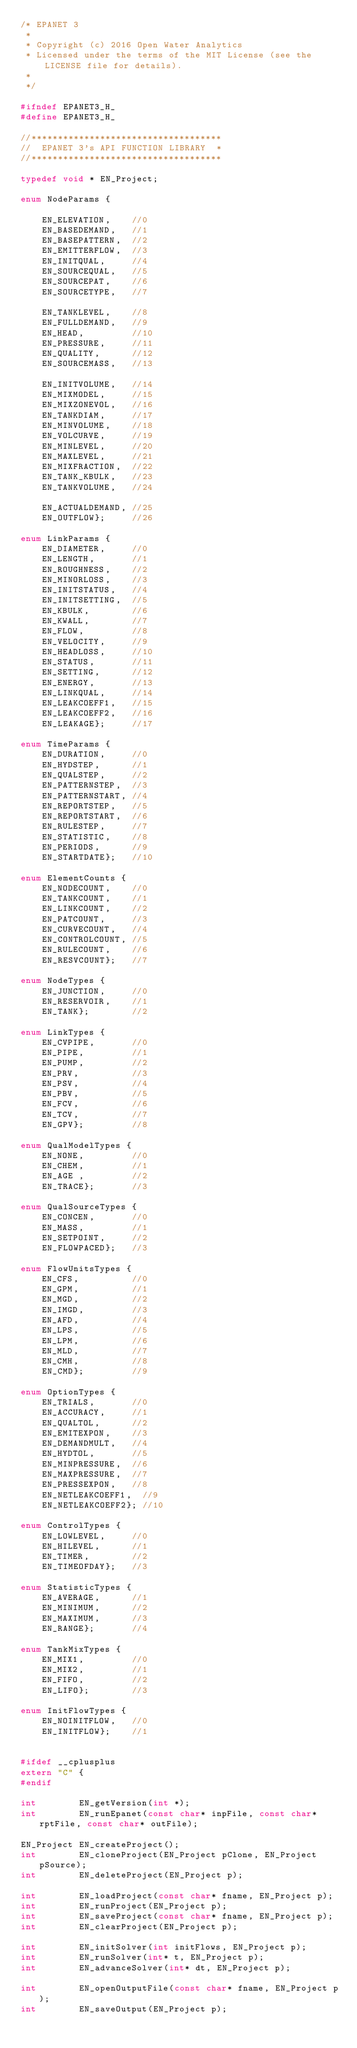Convert code to text. <code><loc_0><loc_0><loc_500><loc_500><_C_>/* EPANET 3
 *
 * Copyright (c) 2016 Open Water Analytics
 * Licensed under the terms of the MIT License (see the LICENSE file for details).
 *
 */

#ifndef EPANET3_H_
#define EPANET3_H_

//************************************
//  EPANET 3's API FUNCTION LIBRARY  *
//************************************

typedef void * EN_Project;

enum NodeParams {

    EN_ELEVATION,    //0
    EN_BASEDEMAND,   //1
    EN_BASEPATTERN,  //2
    EN_EMITTERFLOW,  //3
    EN_INITQUAL,     //4
    EN_SOURCEQUAL,   //5
    EN_SOURCEPAT,    //6
    EN_SOURCETYPE,   //7

    EN_TANKLEVEL,    //8
    EN_FULLDEMAND,   //9
    EN_HEAD,         //10
    EN_PRESSURE,     //11
    EN_QUALITY,      //12
    EN_SOURCEMASS,   //13

    EN_INITVOLUME,   //14
    EN_MIXMODEL,     //15
    EN_MIXZONEVOL,   //16
    EN_TANKDIAM,     //17
    EN_MINVOLUME,    //18
    EN_VOLCURVE,     //19
    EN_MINLEVEL,     //20
    EN_MAXLEVEL,     //21
    EN_MIXFRACTION,  //22
    EN_TANK_KBULK,   //23
    EN_TANKVOLUME,   //24

    EN_ACTUALDEMAND, //25
    EN_OUTFLOW};     //26

enum LinkParams {
    EN_DIAMETER,     //0
    EN_LENGTH,       //1
    EN_ROUGHNESS,    //2
    EN_MINORLOSS,    //3
    EN_INITSTATUS,   //4
    EN_INITSETTING,  //5
    EN_KBULK,        //6
    EN_KWALL,        //7
    EN_FLOW,         //8
    EN_VELOCITY,     //9
    EN_HEADLOSS,     //10
    EN_STATUS,       //11
    EN_SETTING,      //12
    EN_ENERGY,       //13
    EN_LINKQUAL,     //14
    EN_LEAKCOEFF1,   //15
    EN_LEAKCOEFF2,   //16
    EN_LEAKAGE};     //17

enum TimeParams {
    EN_DURATION,     //0
    EN_HYDSTEP,      //1
    EN_QUALSTEP,     //2
    EN_PATTERNSTEP,  //3
    EN_PATTERNSTART, //4
    EN_REPORTSTEP,   //5
    EN_REPORTSTART,  //6
    EN_RULESTEP,     //7
    EN_STATISTIC,    //8
    EN_PERIODS,      //9
    EN_STARTDATE};   //10

enum ElementCounts {
    EN_NODECOUNT,    //0
    EN_TANKCOUNT,    //1
    EN_LINKCOUNT,    //2
    EN_PATCOUNT,     //3
    EN_CURVECOUNT,   //4
    EN_CONTROLCOUNT, //5
    EN_RULECOUNT,    //6
    EN_RESVCOUNT};   //7

enum NodeTypes {
    EN_JUNCTION,     //0
    EN_RESERVOIR,    //1
    EN_TANK};        //2

enum LinkTypes {
    EN_CVPIPE,       //0
    EN_PIPE,         //1
    EN_PUMP,         //2
    EN_PRV,          //3
    EN_PSV,          //4
    EN_PBV,          //5
    EN_FCV,          //6
    EN_TCV,          //7
    EN_GPV};         //8

enum QualModelTypes {
    EN_NONE,         //0
    EN_CHEM,         //1
    EN_AGE ,         //2
    EN_TRACE};       //3

enum QualSourceTypes {
    EN_CONCEN,       //0
    EN_MASS,         //1
    EN_SETPOINT,     //2
    EN_FLOWPACED};   //3

enum FlowUnitsTypes {
    EN_CFS,          //0
    EN_GPM,          //1
    EN_MGD,          //2
    EN_IMGD,         //3
    EN_AFD,          //4
    EN_LPS,          //5
    EN_LPM,          //6
    EN_MLD,          //7
    EN_CMH,          //8
    EN_CMD};         //9

enum OptionTypes {
    EN_TRIALS,       //0
    EN_ACCURACY,     //1
    EN_QUALTOL,      //2
    EN_EMITEXPON,    //3
    EN_DEMANDMULT,   //4
    EN_HYDTOL,       //5
    EN_MINPRESSURE,  //6
    EN_MAXPRESSURE,  //7
    EN_PRESSEXPON,   //8
    EN_NETLEAKCOEFF1,  //9
    EN_NETLEAKCOEFF2}; //10

enum ControlTypes {
    EN_LOWLEVEL,     //0
    EN_HILEVEL,      //1
    EN_TIMER,        //2
    EN_TIMEOFDAY};   //3

enum StatisticTypes {
    EN_AVERAGE,      //1
    EN_MINIMUM,      //2
    EN_MAXIMUM,      //3
    EN_RANGE};       //4

enum TankMixTypes {
    EN_MIX1,         //0
    EN_MIX2,         //1
    EN_FIFO,         //2
    EN_LIFO};        //3

enum InitFlowTypes {
    EN_NOINITFLOW,   //0
    EN_INITFLOW};    //1


#ifdef __cplusplus
extern "C" {
#endif

int        EN_getVersion(int *);
int        EN_runEpanet(const char* inpFile, const char* rptFile, const char* outFile);

EN_Project EN_createProject();
int        EN_cloneProject(EN_Project pClone, EN_Project pSource);
int        EN_deleteProject(EN_Project p);

int        EN_loadProject(const char* fname, EN_Project p);
int        EN_runProject(EN_Project p);
int        EN_saveProject(const char* fname, EN_Project p);
int        EN_clearProject(EN_Project p);

int        EN_initSolver(int initFlows, EN_Project p);
int        EN_runSolver(int* t, EN_Project p);
int        EN_advanceSolver(int* dt, EN_Project p);

int        EN_openOutputFile(const char* fname, EN_Project p);
int        EN_saveOutput(EN_Project p);
</code> 